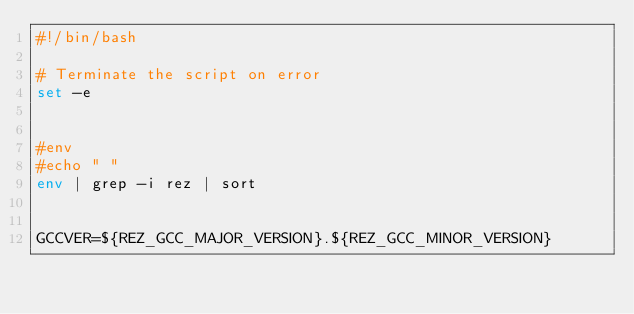<code> <loc_0><loc_0><loc_500><loc_500><_Bash_>#!/bin/bash

# Terminate the script on error
set -e


#env
#echo " "
env | grep -i rez | sort


GCCVER=${REZ_GCC_MAJOR_VERSION}.${REZ_GCC_MINOR_VERSION}</code> 